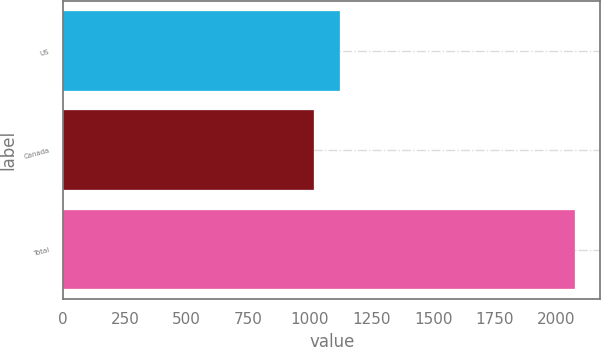Convert chart to OTSL. <chart><loc_0><loc_0><loc_500><loc_500><bar_chart><fcel>US<fcel>Canada<fcel>Total<nl><fcel>1120.9<fcel>1015<fcel>2074<nl></chart> 